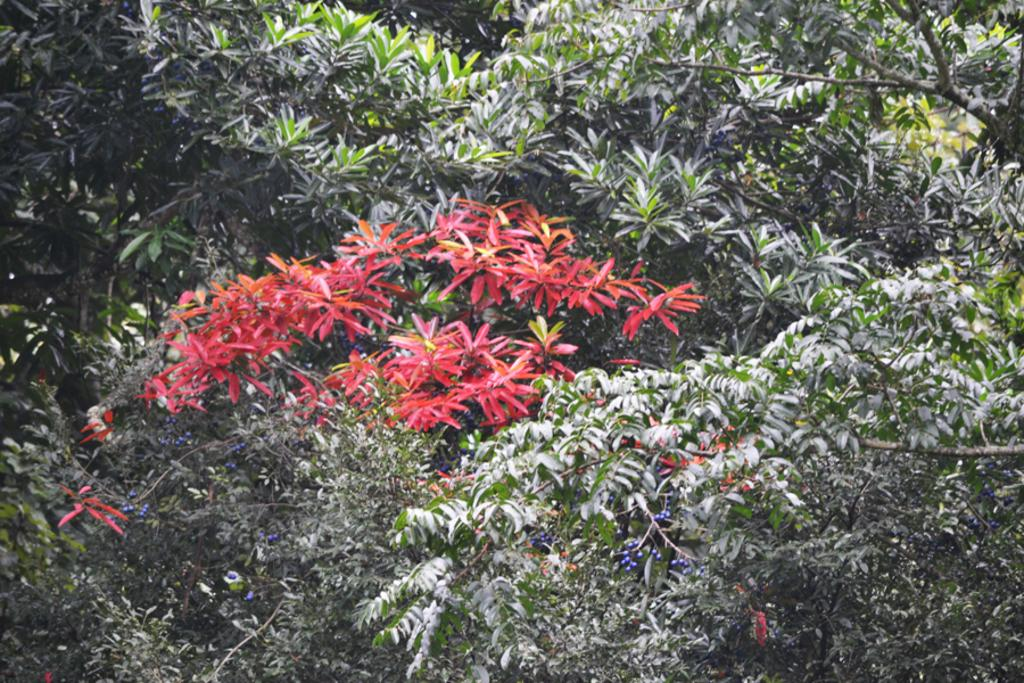What type of vegetation can be seen in the image? There are trees in the image. Can you describe the trees in the image? The provided facts do not give specific details about the trees, so we cannot describe them further. What type of rod can be seen in the image? There is no rod present in the image; it only features trees. 